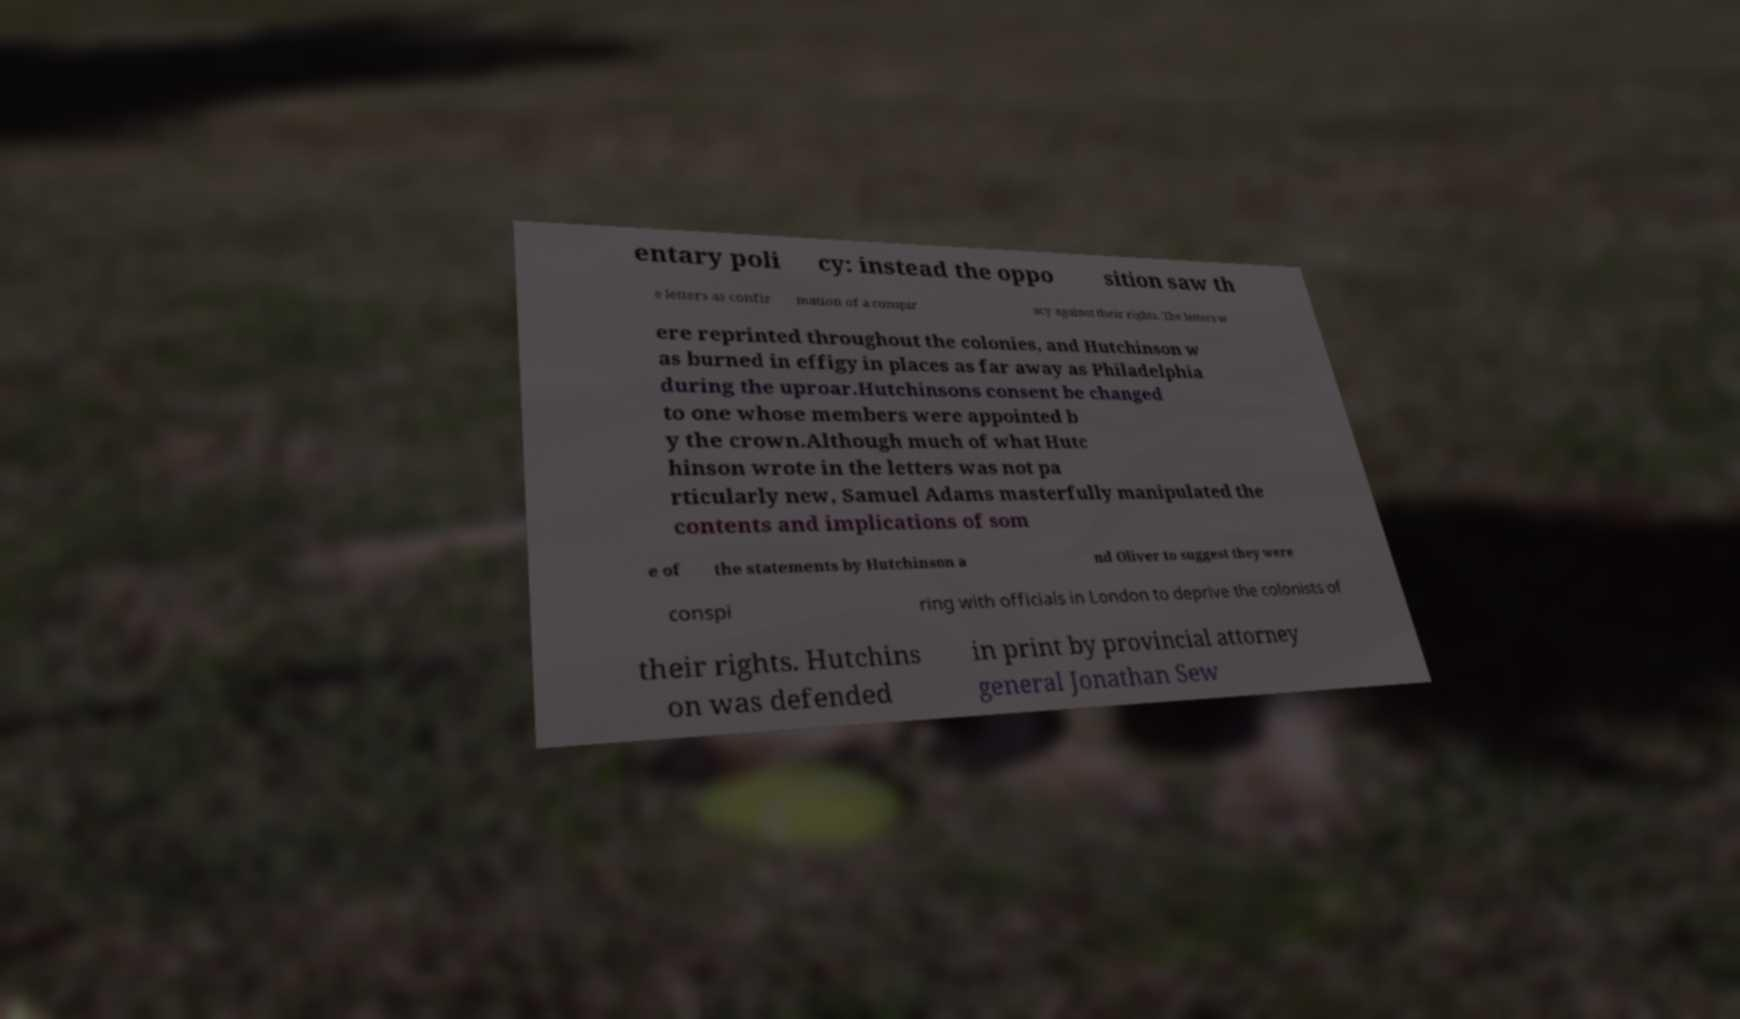There's text embedded in this image that I need extracted. Can you transcribe it verbatim? entary poli cy: instead the oppo sition saw th e letters as confir mation of a conspir acy against their rights. The letters w ere reprinted throughout the colonies, and Hutchinson w as burned in effigy in places as far away as Philadelphia during the uproar.Hutchinsons consent be changed to one whose members were appointed b y the crown.Although much of what Hutc hinson wrote in the letters was not pa rticularly new, Samuel Adams masterfully manipulated the contents and implications of som e of the statements by Hutchinson a nd Oliver to suggest they were conspi ring with officials in London to deprive the colonists of their rights. Hutchins on was defended in print by provincial attorney general Jonathan Sew 